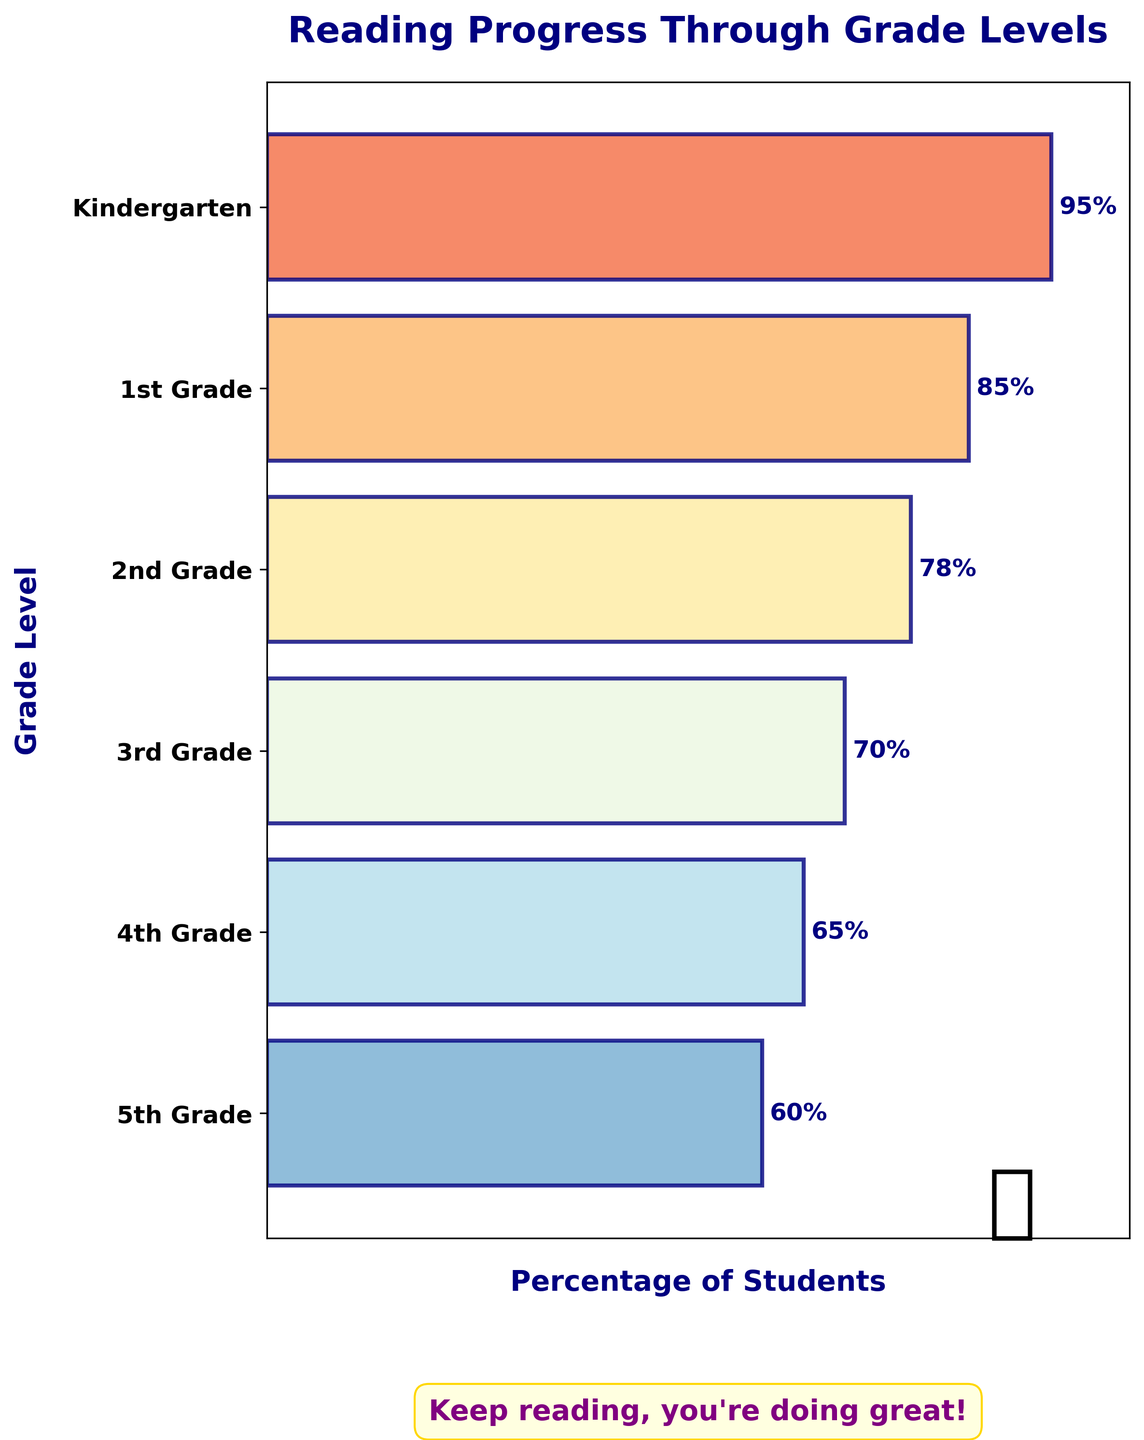What's the title of the chart? The title is found at the top of the chart and is written in a larger, bold font.
Answer: Reading Progress Through Grade Levels How many grade levels are shown in the chart? Count the unique labels on the y-axis of the chart. There are six labels corresponding to six grade levels.
Answer: 6 Which grade level has the highest percentage of students reading at grade level? Look at the bars and see which is the longest, corresponding to the largest percentage label. It's the topmost bar for Kindergarten.
Answer: Kindergarten What color are the bars representing the different grade levels? The bars use a gradient color scheme from one color to another. Observe the colors used in the bars.
Answer: Varied (shades from red to blue) From Kindergarten to 5th Grade, which grade level shows the largest drop in the percentage of students reading at grade level? Compare the percentages between each consecutive grade. The largest drop is between Kindergarten (95%) and 1st Grade (85%).
Answer: Kindergarten to 1st Grade What is the percentage of students reading at grade level in 4th Grade? Locate the bar labeled 4th Grade and read the percentage indicated next to it.
Answer: 65% How many more students are reading at grade level in Kindergarten compared to 2nd Grade? Subtract the percentage of 2nd Grade from Kindergarten (95% - 78%).
Answer: 17% Which grade levels have a percentage of students reading at grade level above 80%? Identify the bars with percentage labels above 80%. These are Kindergarten and 1st Grade.
Answer: Kindergarten and 1st Grade How does the percentage of students reading at grade level change as the grade levels increase? Generally examine the trend from Kindergarten to 5th Grade. The percentages decrease as the grade level increases.
Answer: Decreases What encouraging message is included in the chart? Look at the box or text displayed at the bottom of the chart for a positive message.
Answer: Keep reading, you're doing great! 